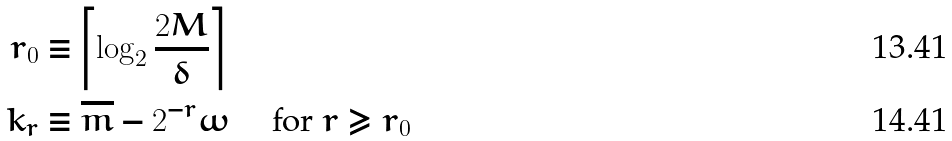<formula> <loc_0><loc_0><loc_500><loc_500>r _ { 0 } & \equiv \left \lceil \log _ { 2 } \frac { 2 M } { \delta } \right \rceil \\ k _ { r } & \equiv \overline { m } - 2 ^ { - r } \omega \quad \text { for } r \geq r _ { 0 }</formula> 